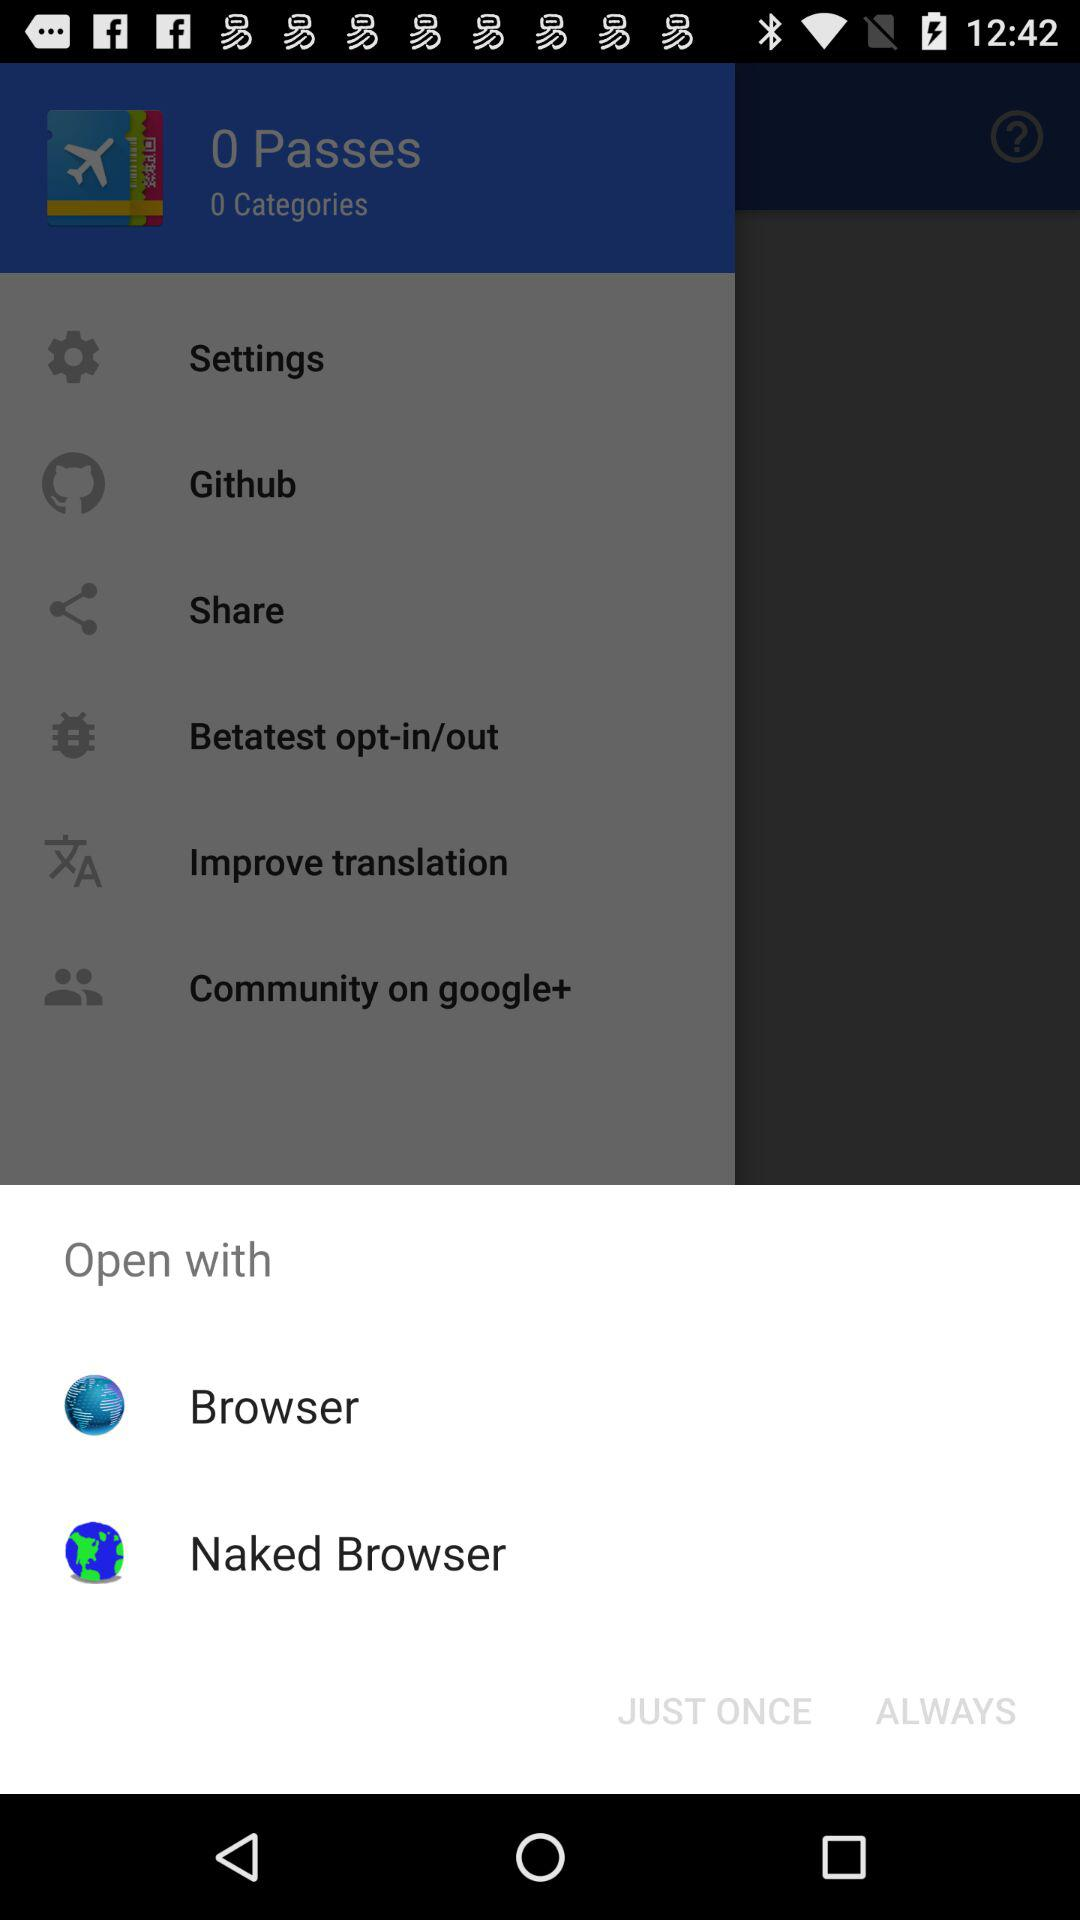Whose account is shown on the screen?
When the provided information is insufficient, respond with <no answer>. <no answer> 